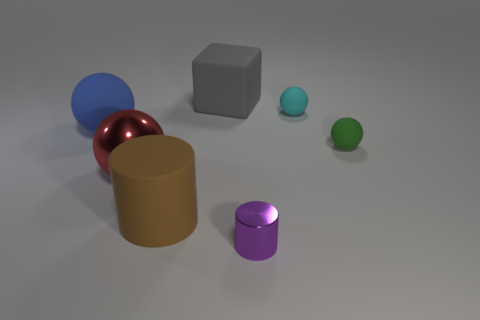There is a cube; is its color the same as the metal object on the left side of the brown cylinder?
Offer a terse response. No. How many gray things have the same shape as the tiny purple shiny object?
Ensure brevity in your answer.  0. What is the sphere that is left of the big red ball made of?
Your answer should be compact. Rubber. There is a metallic object that is to the right of the big red thing; does it have the same shape as the gray rubber object?
Your answer should be very brief. No. Is there a brown rubber cube that has the same size as the green ball?
Make the answer very short. No. There is a big blue matte object; is its shape the same as the shiny object that is left of the big cube?
Give a very brief answer. Yes. Are there fewer big red objects that are behind the blue matte sphere than large brown things?
Your response must be concise. Yes. Does the small green thing have the same shape as the blue rubber thing?
Your answer should be very brief. Yes. There is a cyan ball that is the same material as the green ball; what size is it?
Provide a short and direct response. Small. Is the number of large blue metallic blocks less than the number of blue matte balls?
Provide a short and direct response. Yes. 